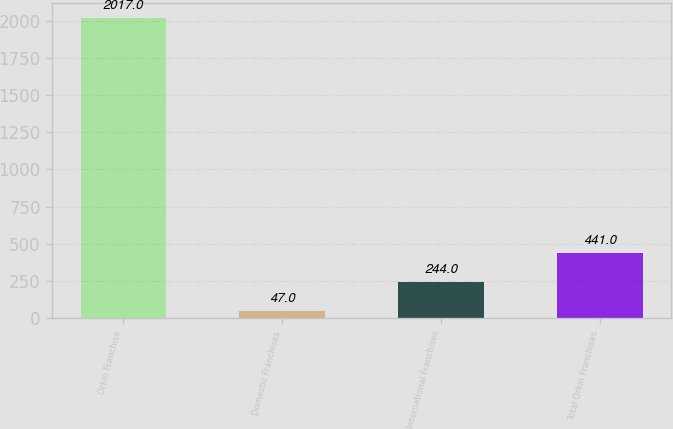Convert chart. <chart><loc_0><loc_0><loc_500><loc_500><bar_chart><fcel>Orkin Franchise<fcel>Domestic Franchises<fcel>International Franchises<fcel>Total Orkin Franchises<nl><fcel>2017<fcel>47<fcel>244<fcel>441<nl></chart> 